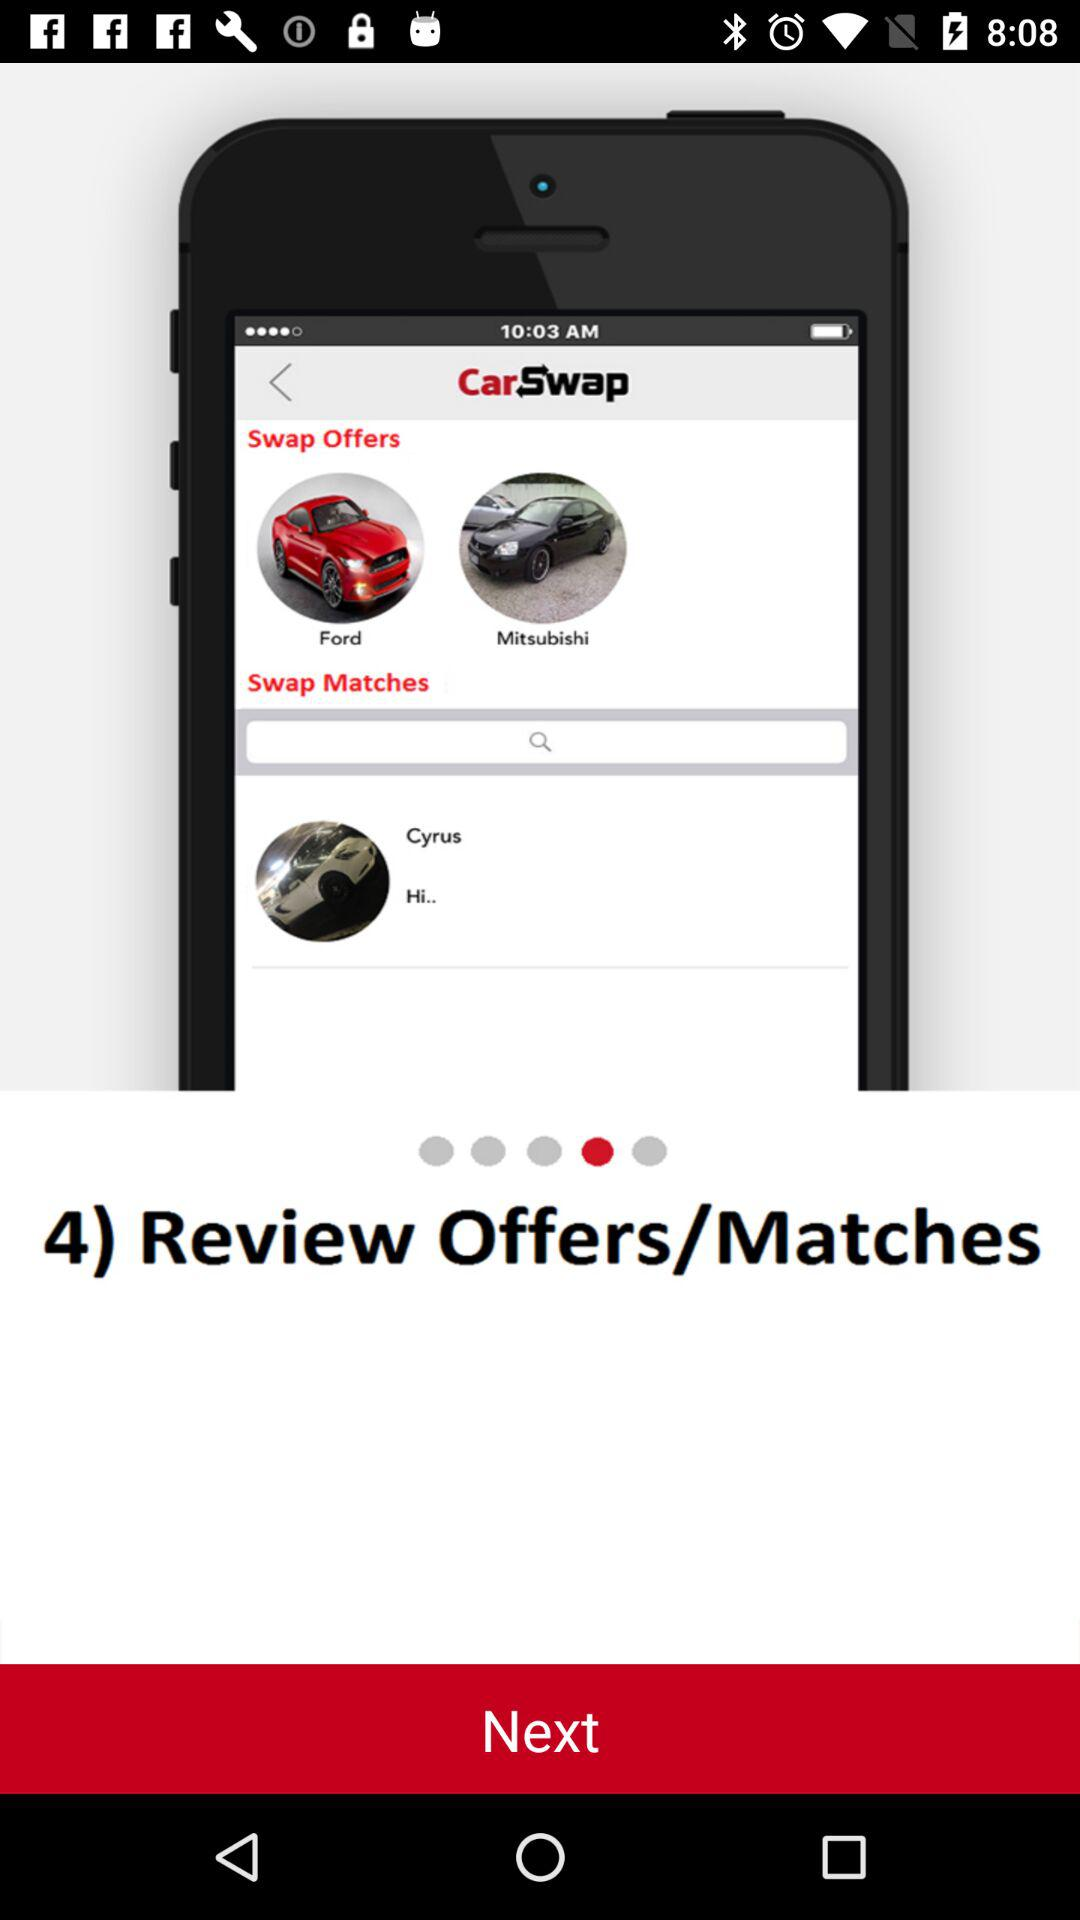What time is shown on the mobile screen? The time that is shown on the mobile screen is 10:03 AM. 